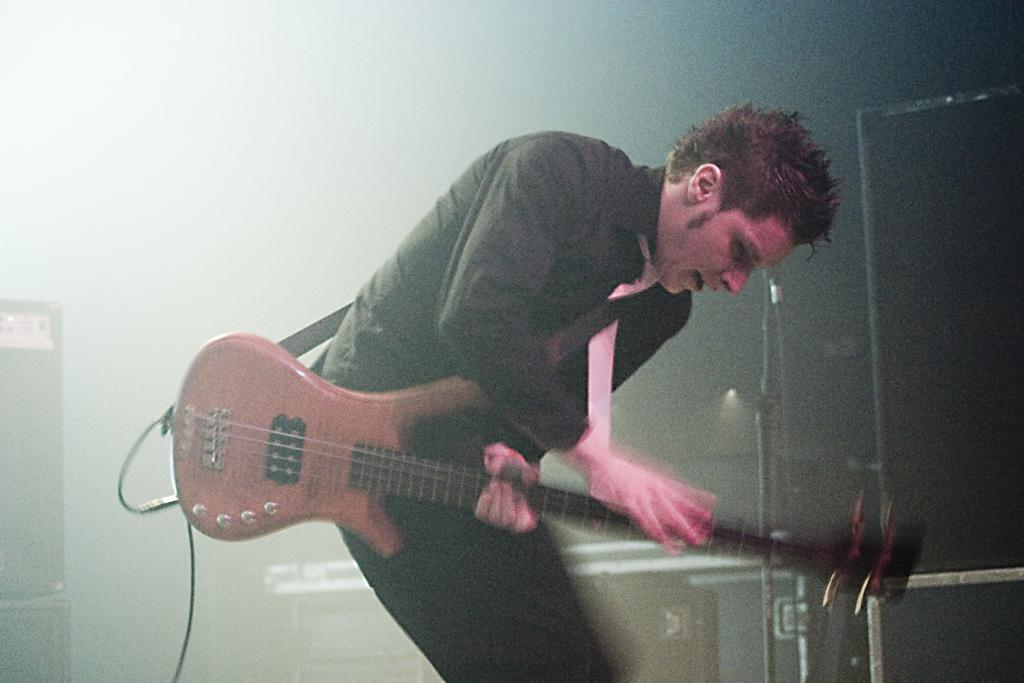What is the man in the image doing? The man is playing a guitar. Where is the man located in the image? The man is on a stage. What instrument is the man playing in the image? The man is playing a guitar. What color is the ink used to write the lyrics on the sheet music in the image? There is no sheet music or ink present in the image; it only shows a man playing a guitar on a stage. 